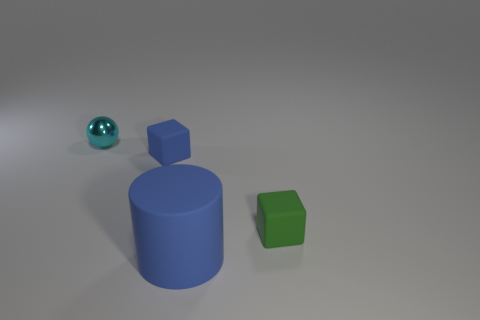Does the block that is on the left side of the large cylinder have the same color as the big cylinder?
Provide a succinct answer. Yes. How many things are small cyan rubber balls or tiny rubber objects behind the green rubber thing?
Provide a succinct answer. 1. What is the tiny object that is both to the left of the cylinder and in front of the small sphere made of?
Provide a short and direct response. Rubber. There is a thing behind the blue block; what is it made of?
Your answer should be very brief. Metal. The other block that is the same material as the small blue block is what color?
Make the answer very short. Green. Do the big blue rubber object and the blue thing that is behind the green object have the same shape?
Your answer should be very brief. No. Are there any tiny green matte cubes to the left of the blue matte cube?
Provide a succinct answer. No. There is a small object that is the same color as the big thing; what material is it?
Your response must be concise. Rubber. Do the sphere and the thing that is to the right of the large blue rubber thing have the same size?
Provide a short and direct response. Yes. Are there any tiny metal balls of the same color as the small shiny object?
Offer a very short reply. No. 